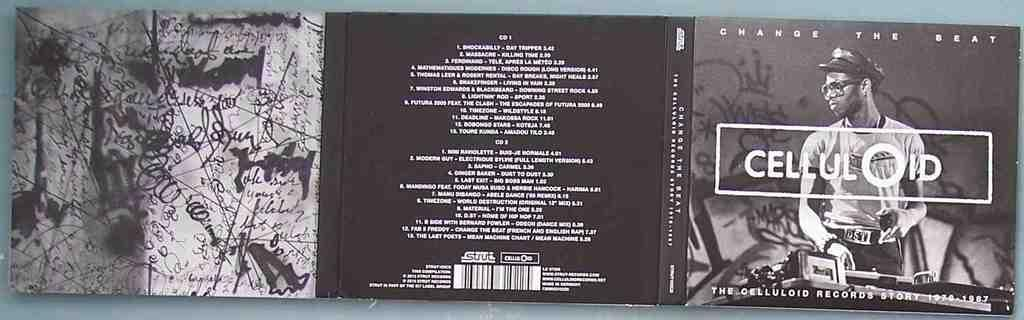Provide a one-sentence caption for the provided image. A CD jacket of a band name CELLULOID. 